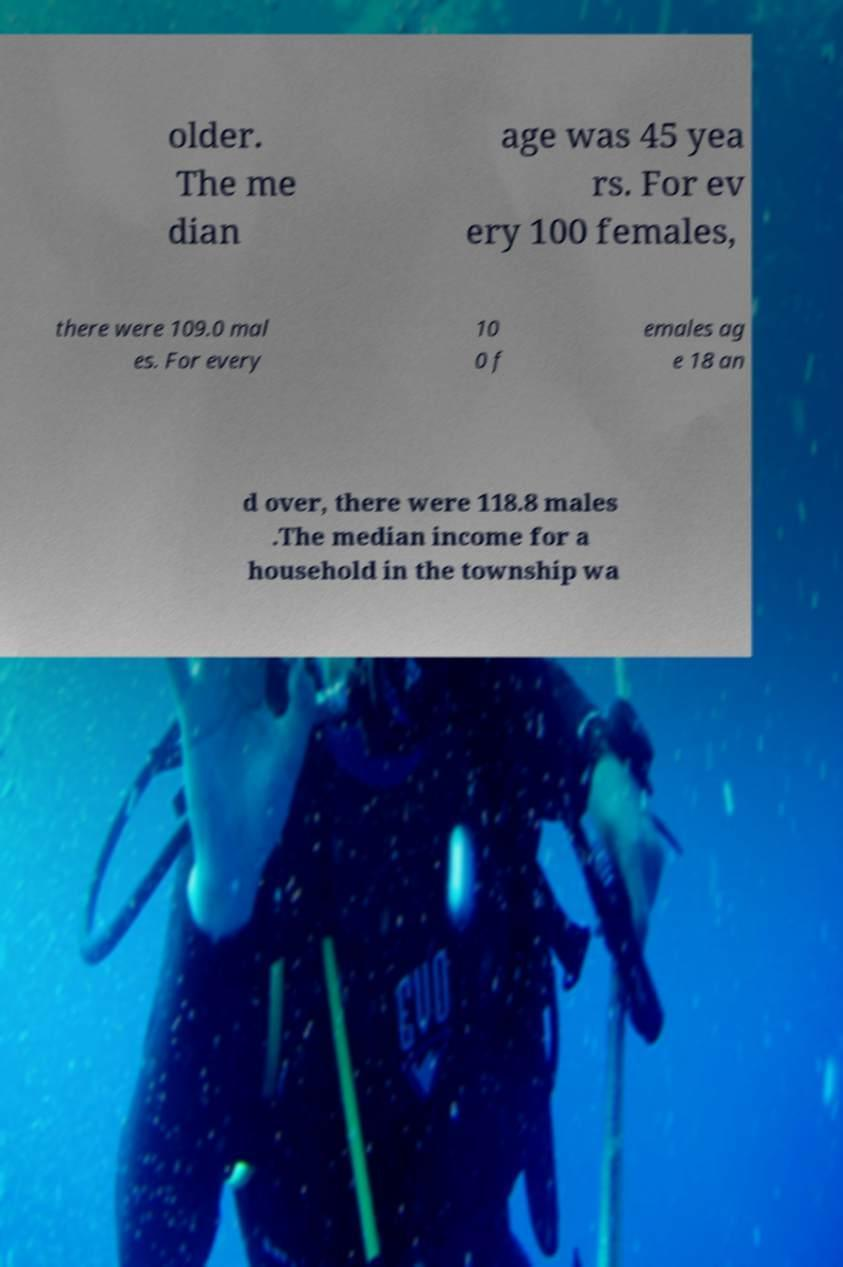Could you assist in decoding the text presented in this image and type it out clearly? older. The me dian age was 45 yea rs. For ev ery 100 females, there were 109.0 mal es. For every 10 0 f emales ag e 18 an d over, there were 118.8 males .The median income for a household in the township wa 